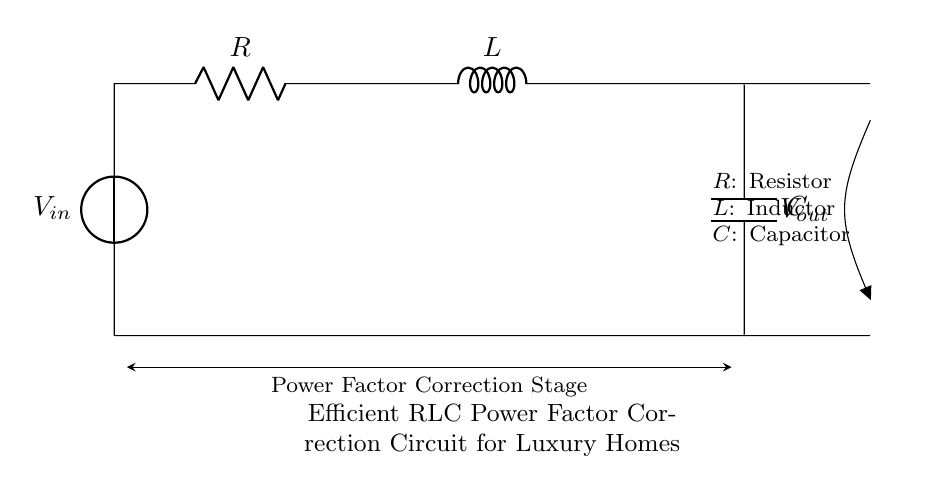What is the voltage source in this circuit? The voltage source in the circuit is labeled as \( V_{in} \), which indicates the input voltage supplied to the circuit.
Answer: Vin What are the components present in this RLC circuit? The components of the circuit include a resistor \( R \), an inductor \( L \), and a capacitor \( C \). These are clearly labeled in the circuit diagram.
Answer: Resistor, inductor, capacitor What type of circuit is this? This circuit is classified as an RLC circuit, which is a common power factor correction circuit using a combination of resistor, inductor, and capacitor for energy optimization.
Answer: RLC circuit What is the purpose of this circuit? The purpose of this circuit is to act as a power factor correction stage, helping to improve energy efficiency in luxury homes by optimizing the power factor of the electrical system.
Answer: Power factor correction Which component is connected in parallel with the inductor? The component that is connected in parallel with the inductor is the capacitor \( C \), which is shown directly below the inductor and is crucial for tuning the circuit's power factor.
Answer: Capacitor What does the output voltage \( V_{out} \) signify in this circuit? The output voltage \( V_{out} \) represents the voltage level obtained after the power factor correction has been applied within the circuit, indicating the corrected voltage to be supplied to the load.
Answer: Vout What is the main stage of this circuit design? The main stage of this circuit design is indicated as the power factor correction stage, which optimally utilizes the arrangement of the resistor, inductor, and capacitor to enhance efficiency.
Answer: Power factor correction stage 